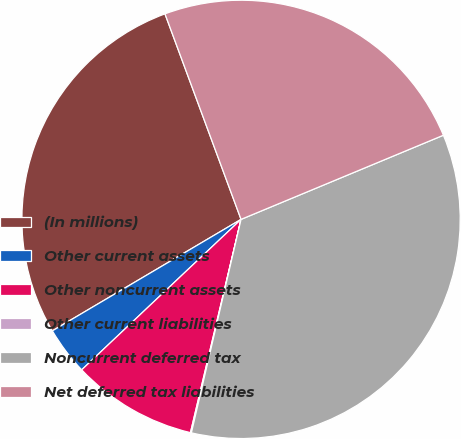Convert chart to OTSL. <chart><loc_0><loc_0><loc_500><loc_500><pie_chart><fcel>(In millions)<fcel>Other current assets<fcel>Other noncurrent assets<fcel>Other current liabilities<fcel>Noncurrent deferred tax<fcel>Net deferred tax liabilities<nl><fcel>27.85%<fcel>3.55%<fcel>9.25%<fcel>0.07%<fcel>34.91%<fcel>24.37%<nl></chart> 